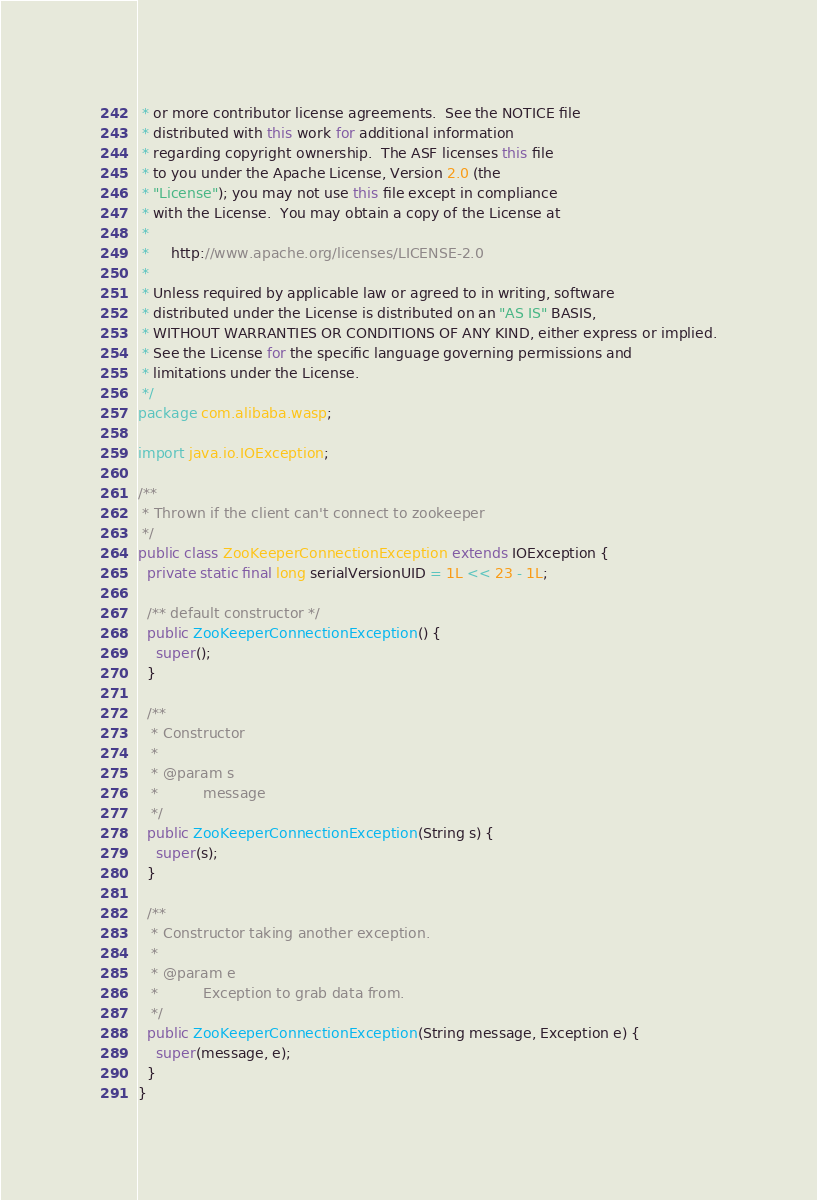Convert code to text. <code><loc_0><loc_0><loc_500><loc_500><_Java_> * or more contributor license agreements.  See the NOTICE file
 * distributed with this work for additional information
 * regarding copyright ownership.  The ASF licenses this file
 * to you under the Apache License, Version 2.0 (the
 * "License"); you may not use this file except in compliance
 * with the License.  You may obtain a copy of the License at
 *
 *     http://www.apache.org/licenses/LICENSE-2.0
 *
 * Unless required by applicable law or agreed to in writing, software
 * distributed under the License is distributed on an "AS IS" BASIS,
 * WITHOUT WARRANTIES OR CONDITIONS OF ANY KIND, either express or implied.
 * See the License for the specific language governing permissions and
 * limitations under the License.
 */
package com.alibaba.wasp;

import java.io.IOException;

/**
 * Thrown if the client can't connect to zookeeper
 */
public class ZooKeeperConnectionException extends IOException {
  private static final long serialVersionUID = 1L << 23 - 1L;

  /** default constructor */
  public ZooKeeperConnectionException() {
    super();
  }

  /**
   * Constructor
   * 
   * @param s
   *          message
   */
  public ZooKeeperConnectionException(String s) {
    super(s);
  }

  /**
   * Constructor taking another exception.
   * 
   * @param e
   *          Exception to grab data from.
   */
  public ZooKeeperConnectionException(String message, Exception e) {
    super(message, e);
  }
}
</code> 